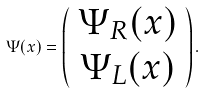Convert formula to latex. <formula><loc_0><loc_0><loc_500><loc_500>\Psi ( x ) = \left ( \begin{array} { c } \Psi _ { R } ( x ) \\ \Psi _ { L } ( x ) \end{array} \right ) .</formula> 